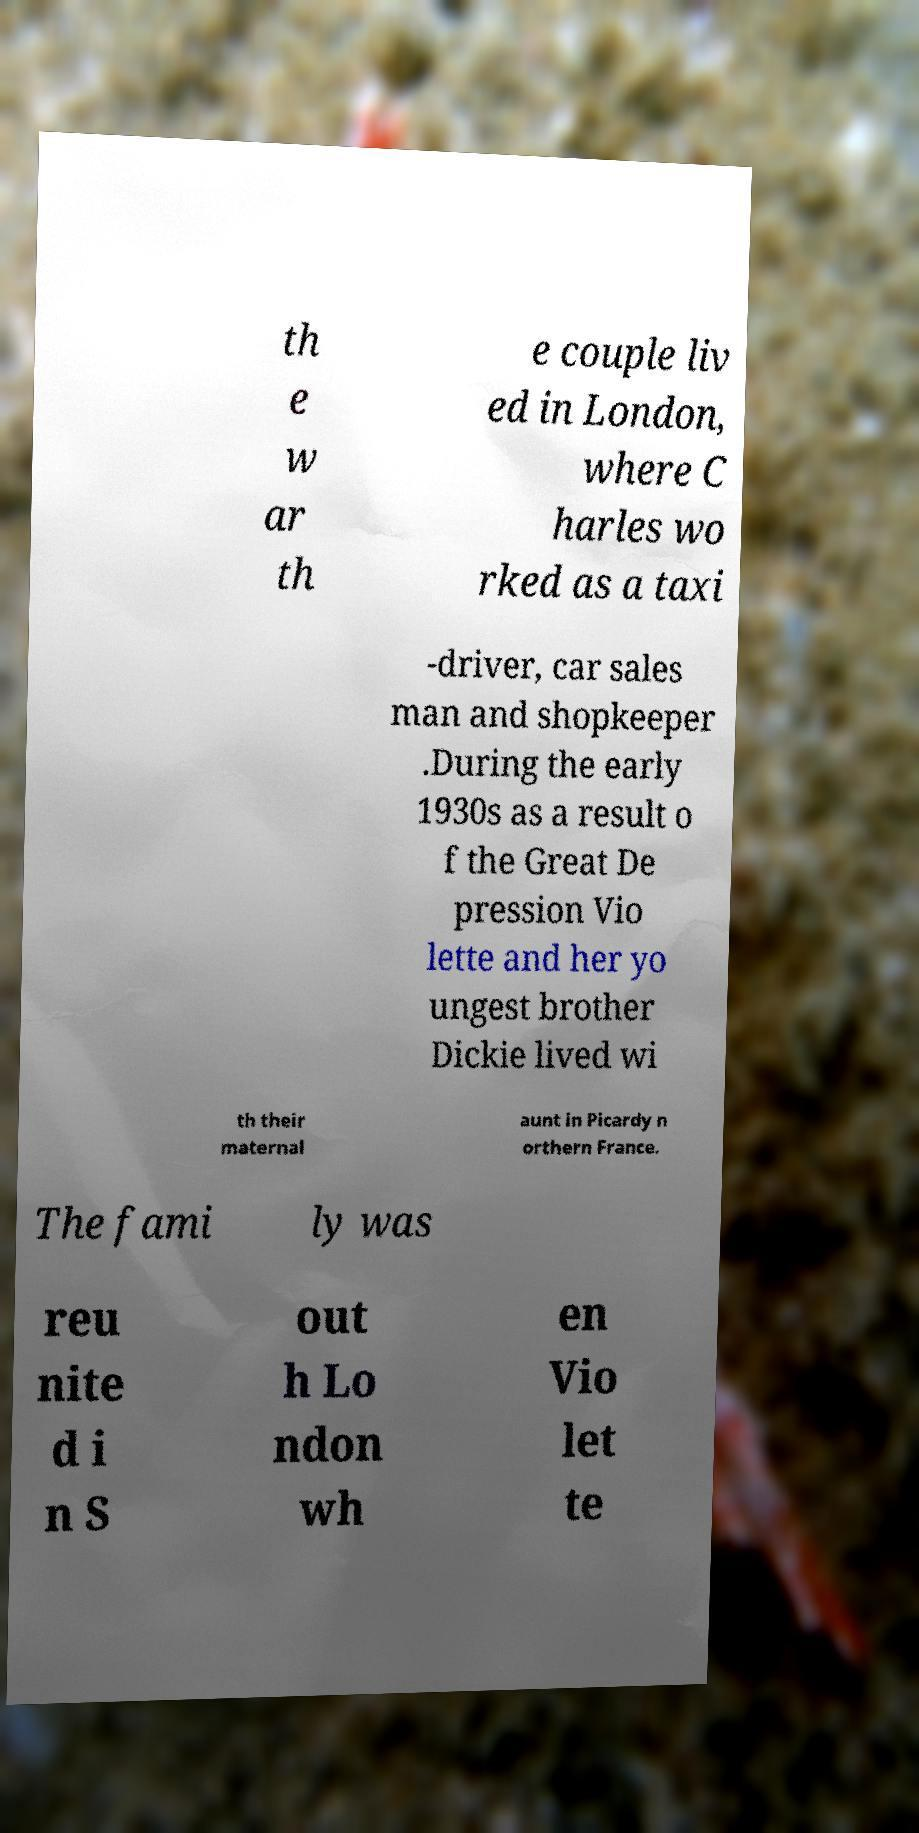I need the written content from this picture converted into text. Can you do that? th e w ar th e couple liv ed in London, where C harles wo rked as a taxi -driver, car sales man and shopkeeper .During the early 1930s as a result o f the Great De pression Vio lette and her yo ungest brother Dickie lived wi th their maternal aunt in Picardy n orthern France. The fami ly was reu nite d i n S out h Lo ndon wh en Vio let te 